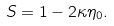<formula> <loc_0><loc_0><loc_500><loc_500>S = 1 - 2 \kappa \eta _ { 0 } .</formula> 